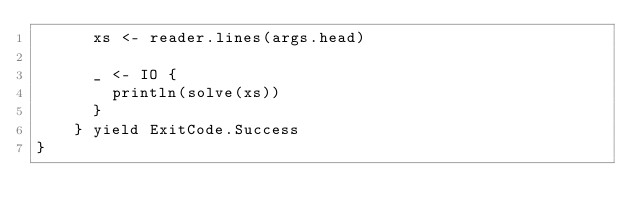<code> <loc_0><loc_0><loc_500><loc_500><_Scala_>      xs <- reader.lines(args.head)

      _ <- IO {
        println(solve(xs))
      }
    } yield ExitCode.Success
}
</code> 